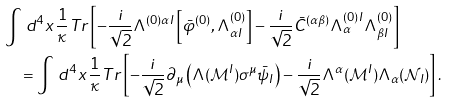Convert formula to latex. <formula><loc_0><loc_0><loc_500><loc_500>& \int \, d ^ { 4 } x \, \frac { 1 } { \kappa } T r \left [ - \frac { i } { \sqrt { 2 } } \Lambda ^ { ( 0 ) \alpha I } \left [ \bar { \varphi } ^ { ( 0 ) } , \Lambda _ { \alpha I } ^ { ( 0 ) } \right ] - \frac { i } { \sqrt { 2 } } \bar { C } ^ { ( \alpha \beta ) } \Lambda _ { \alpha } ^ { ( 0 ) I } \Lambda _ { \beta I } ^ { ( 0 ) } \right ] \\ & \quad = \int \, d ^ { 4 } x \, \frac { 1 } { \kappa } T r \left [ - \frac { i } { \sqrt { 2 } } \partial _ { \mu } \left ( \Lambda ( \mathcal { M } ^ { I } ) \sigma ^ { \mu } \bar { \psi } _ { I } \right ) - \frac { i } { \sqrt { 2 } } \Lambda ^ { \alpha } ( \mathcal { M } ^ { I } ) \Lambda _ { \alpha } ( \mathcal { N } _ { I } ) \right ] .</formula> 